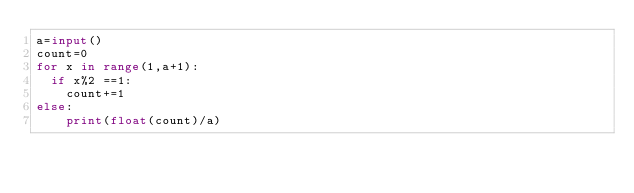<code> <loc_0><loc_0><loc_500><loc_500><_Python_>a=input()
count=0
for x in range(1,a+1):
  if x%2 ==1:
    count+=1
else:
    print(float(count)/a)
  </code> 